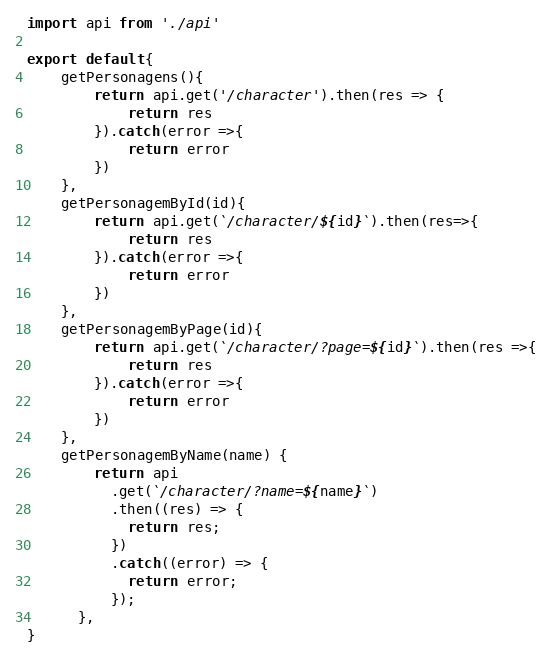Convert code to text. <code><loc_0><loc_0><loc_500><loc_500><_JavaScript_>import api from './api'

export default{
    getPersonagens(){
        return api.get('/character').then(res => {
            return res
        }).catch(error =>{
            return error
        })
    },
    getPersonagemById(id){
        return api.get(`/character/${id}`).then(res=>{
            return res
        }).catch(error =>{
            return error
        })
    },
    getPersonagemByPage(id){
        return api.get(`/character/?page=${id}`).then(res =>{
            return res
        }).catch(error =>{
            return error
        })
    },
    getPersonagemByName(name) {
        return api
          .get(`/character/?name=${name}`)
          .then((res) => {
            return res;
          })
          .catch((error) => {
            return error;
          });
      },
}</code> 